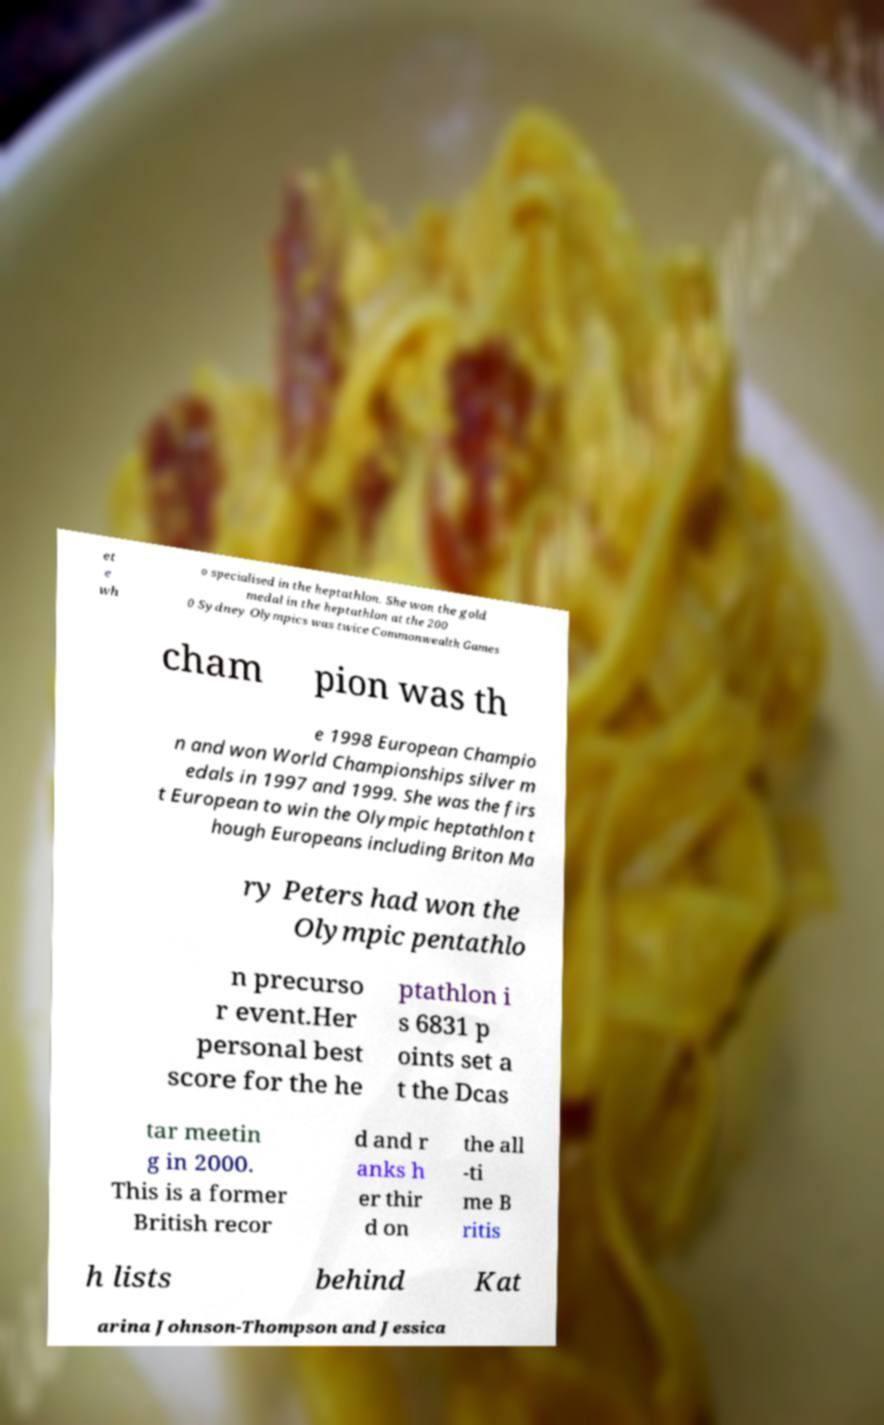Could you extract and type out the text from this image? et e wh o specialised in the heptathlon. She won the gold medal in the heptathlon at the 200 0 Sydney Olympics was twice Commonwealth Games cham pion was th e 1998 European Champio n and won World Championships silver m edals in 1997 and 1999. She was the firs t European to win the Olympic heptathlon t hough Europeans including Briton Ma ry Peters had won the Olympic pentathlo n precurso r event.Her personal best score for the he ptathlon i s 6831 p oints set a t the Dcas tar meetin g in 2000. This is a former British recor d and r anks h er thir d on the all -ti me B ritis h lists behind Kat arina Johnson-Thompson and Jessica 